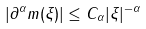<formula> <loc_0><loc_0><loc_500><loc_500>| \partial ^ { \alpha } m ( \xi ) | \leq C _ { \alpha } | \xi | ^ { - \alpha }</formula> 